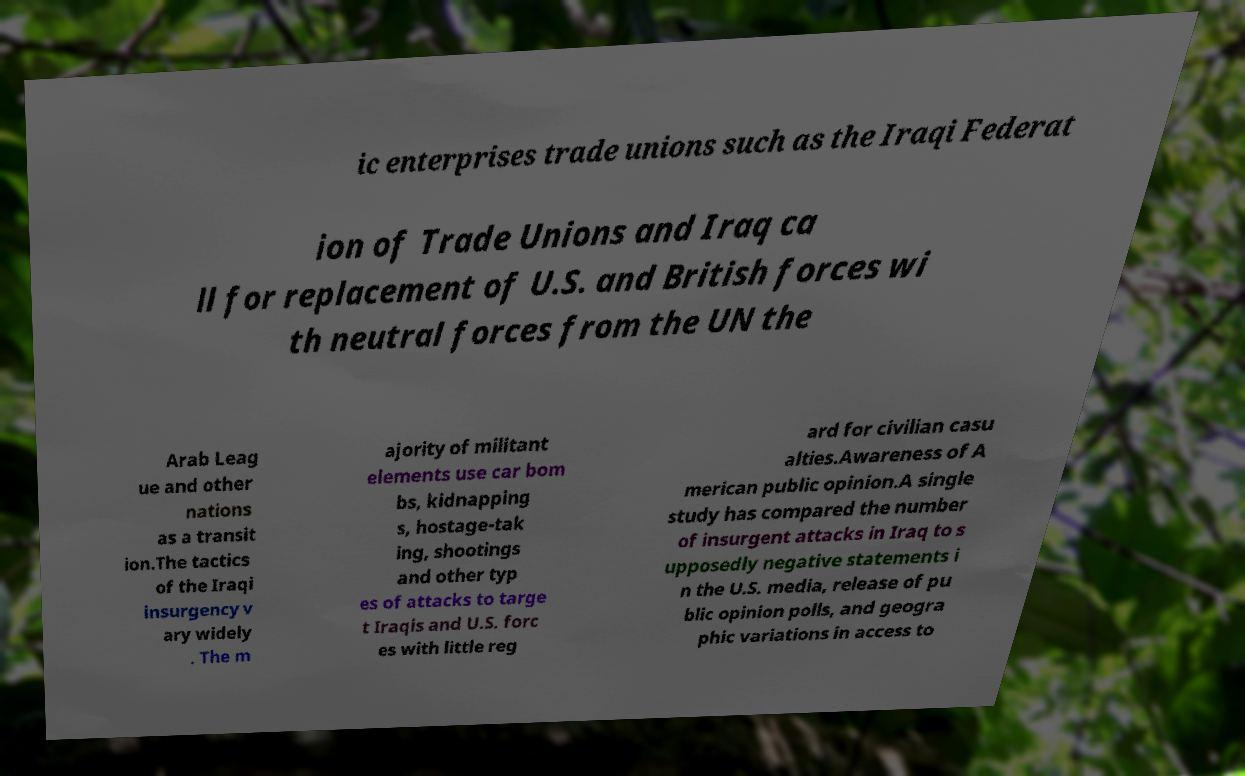There's text embedded in this image that I need extracted. Can you transcribe it verbatim? ic enterprises trade unions such as the Iraqi Federat ion of Trade Unions and Iraq ca ll for replacement of U.S. and British forces wi th neutral forces from the UN the Arab Leag ue and other nations as a transit ion.The tactics of the Iraqi insurgency v ary widely . The m ajority of militant elements use car bom bs, kidnapping s, hostage-tak ing, shootings and other typ es of attacks to targe t Iraqis and U.S. forc es with little reg ard for civilian casu alties.Awareness of A merican public opinion.A single study has compared the number of insurgent attacks in Iraq to s upposedly negative statements i n the U.S. media, release of pu blic opinion polls, and geogra phic variations in access to 